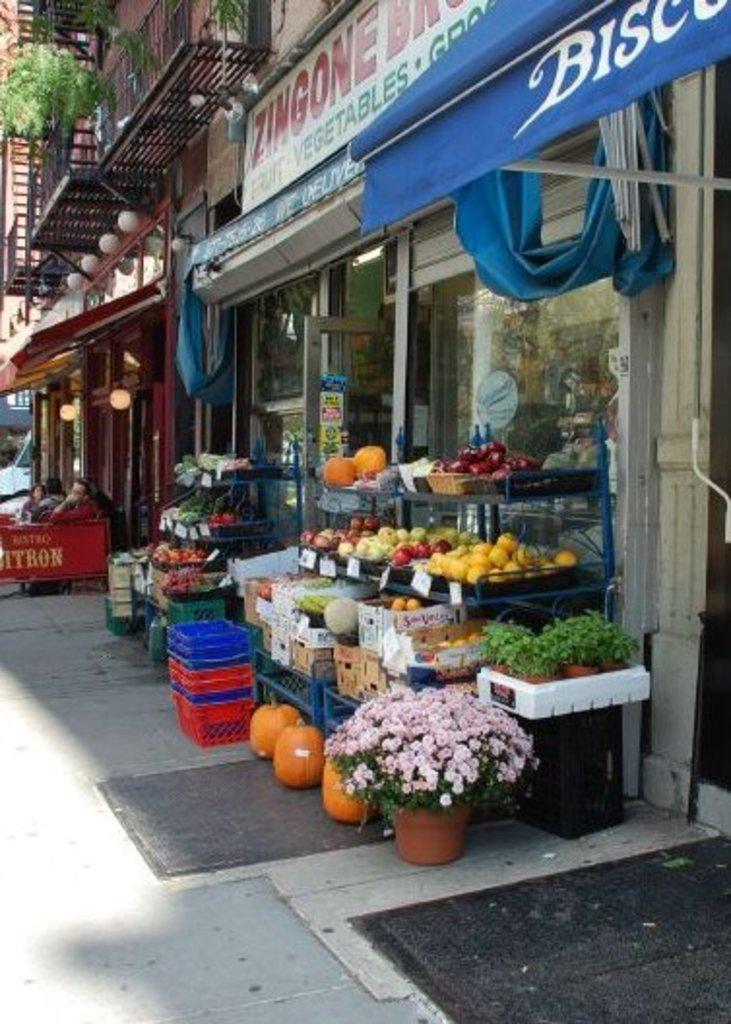Can you describe this image briefly? In this image I can see few fruits and vegetables in the baskets. In front I can see few flowers in pink color. In the background I can see few stalls, lights, plants and few buildings. 